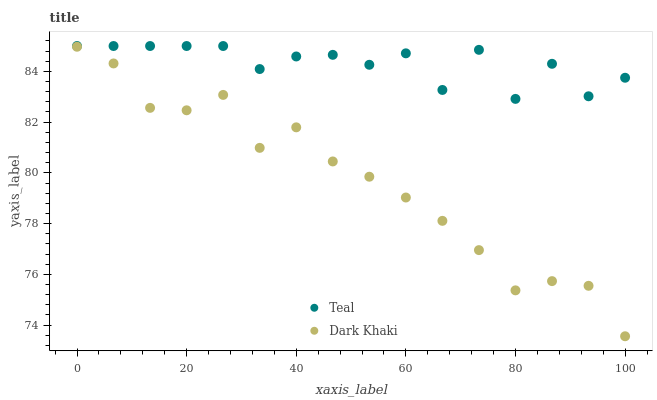Does Dark Khaki have the minimum area under the curve?
Answer yes or no. Yes. Does Teal have the maximum area under the curve?
Answer yes or no. Yes. Does Teal have the minimum area under the curve?
Answer yes or no. No. Is Dark Khaki the smoothest?
Answer yes or no. Yes. Is Teal the roughest?
Answer yes or no. Yes. Is Teal the smoothest?
Answer yes or no. No. Does Dark Khaki have the lowest value?
Answer yes or no. Yes. Does Teal have the lowest value?
Answer yes or no. No. Does Teal have the highest value?
Answer yes or no. Yes. Is Dark Khaki less than Teal?
Answer yes or no. Yes. Is Teal greater than Dark Khaki?
Answer yes or no. Yes. Does Dark Khaki intersect Teal?
Answer yes or no. No. 